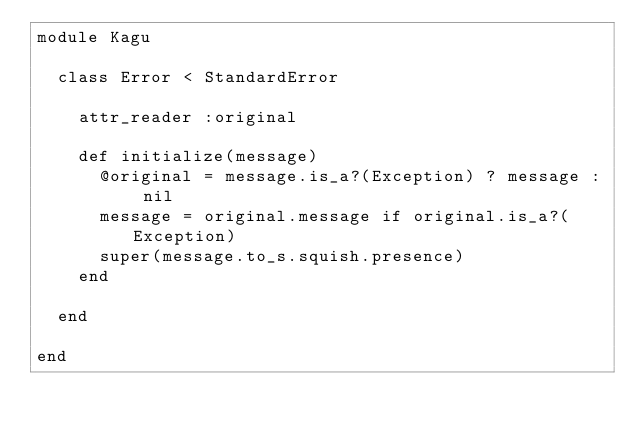Convert code to text. <code><loc_0><loc_0><loc_500><loc_500><_Ruby_>module Kagu

  class Error < StandardError

    attr_reader :original

    def initialize(message)
      @original = message.is_a?(Exception) ? message : nil
      message = original.message if original.is_a?(Exception)
      super(message.to_s.squish.presence)
    end

  end

end
</code> 